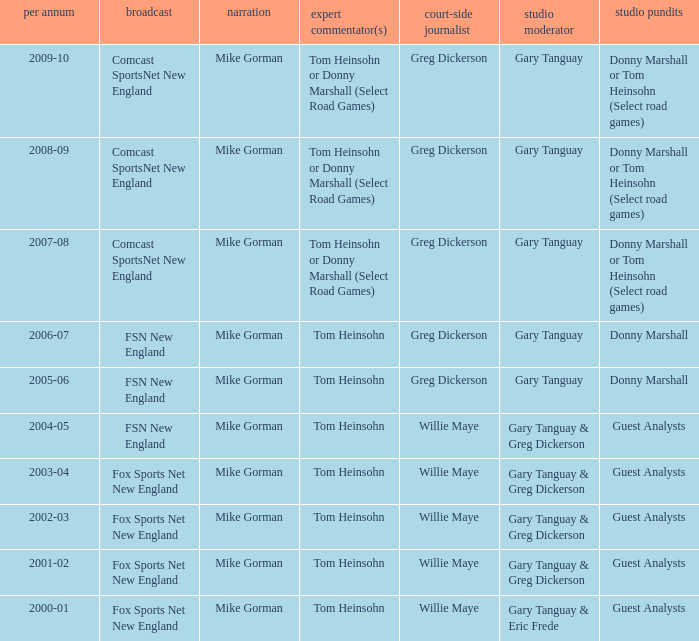WHich Play-by-play has a Studio host of gary tanguay, and a Studio analysts of donny marshall? Mike Gorman, Mike Gorman. 